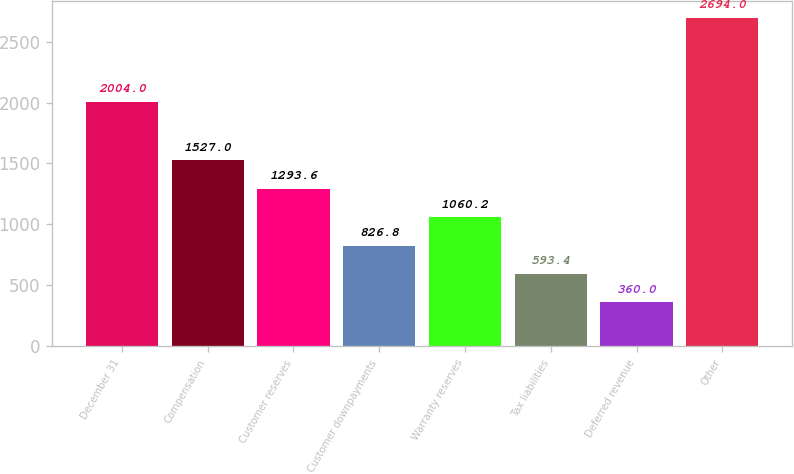<chart> <loc_0><loc_0><loc_500><loc_500><bar_chart><fcel>December 31<fcel>Compensation<fcel>Customer reserves<fcel>Customer downpayments<fcel>Warranty reserves<fcel>Tax liabilities<fcel>Deferred revenue<fcel>Other<nl><fcel>2004<fcel>1527<fcel>1293.6<fcel>826.8<fcel>1060.2<fcel>593.4<fcel>360<fcel>2694<nl></chart> 